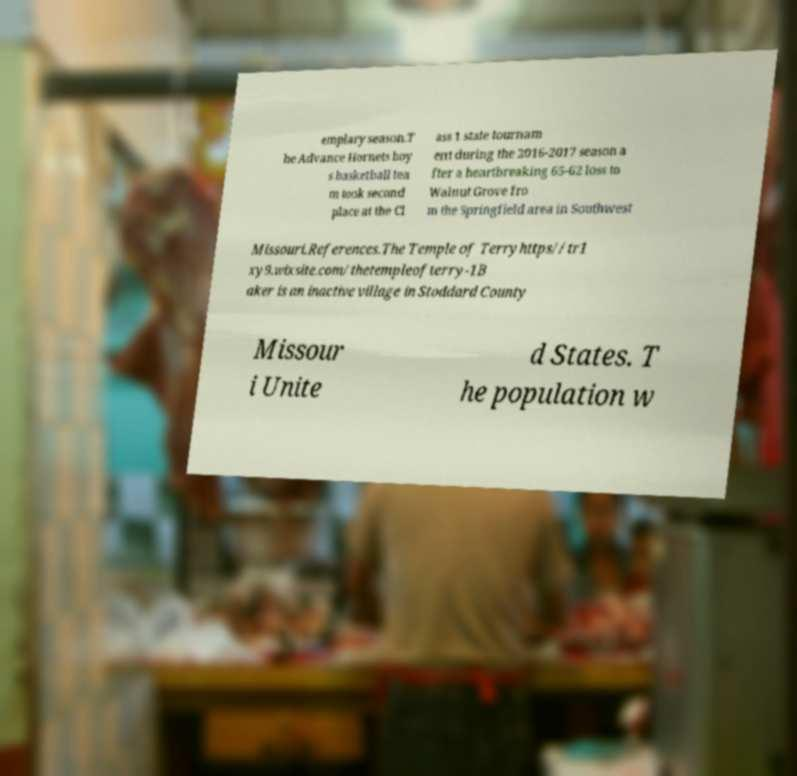What messages or text are displayed in this image? I need them in a readable, typed format. emplary season.T he Advance Hornets boy s basketball tea m took second place at the Cl ass 1 state tournam ent during the 2016-2017 season a fter a heartbreaking 65-62 loss to Walnut Grove fro m the Springfield area in Southwest Missouri.References.The Temple of Terryhttps//tr1 xy9.wixsite.com/thetempleofterry-1B aker is an inactive village in Stoddard County Missour i Unite d States. T he population w 